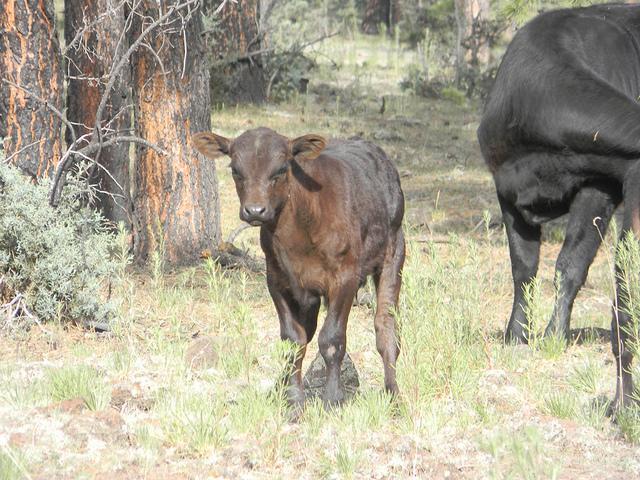How many cows are there?
Give a very brief answer. 2. 